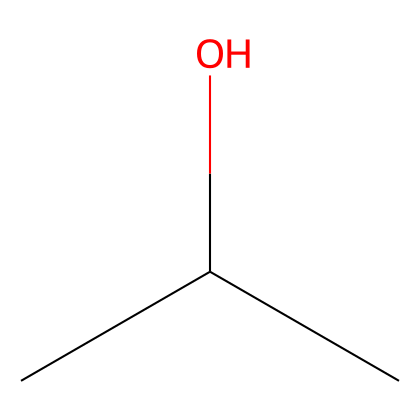What is the name of this chemical? The SMILES representation CC(C)O corresponds to isopropyl alcohol, which is the common name for a compound with this structure.
Answer: isopropyl alcohol How many carbon atoms are in isopropyl alcohol? The SMILES shows CC(C), indicating there are three carbon atoms (C) present in the structure.
Answer: three How many hydroxyl groups are present in isopropyl alcohol? The presence of the -OH group connected to one of the carbon atoms indicates there is one hydroxyl group, which is characteristic of alcohols.
Answer: one What is the degree of branching in the chemical structure? The structure CC(C) indicates branching at the second carbon atom, leading to a branched structure typical of isopropyl alcohol.
Answer: branched What type of solvent is isopropyl alcohol? Isopropyl alcohol is commonly recognized as a polar solvent due to its -OH group, which allows it to dissolve polar substances effectively.
Answer: polar solvent What is the total number of hydrogen atoms in isopropyl alcohol? Each carbon in the structure has enough hydrogen atoms to satisfy carbon's tetravalency. Counting the hydrogens gives a total of eight: (CH₃)₂CHOH.
Answer: eight Is isopropyl alcohol considered a primary, secondary, or tertiary alcohol? The structure shows that the hydroxyl (-OH) group is attached to a carbon that is connected to two other carbons, indicating it is a secondary alcohol.
Answer: secondary 